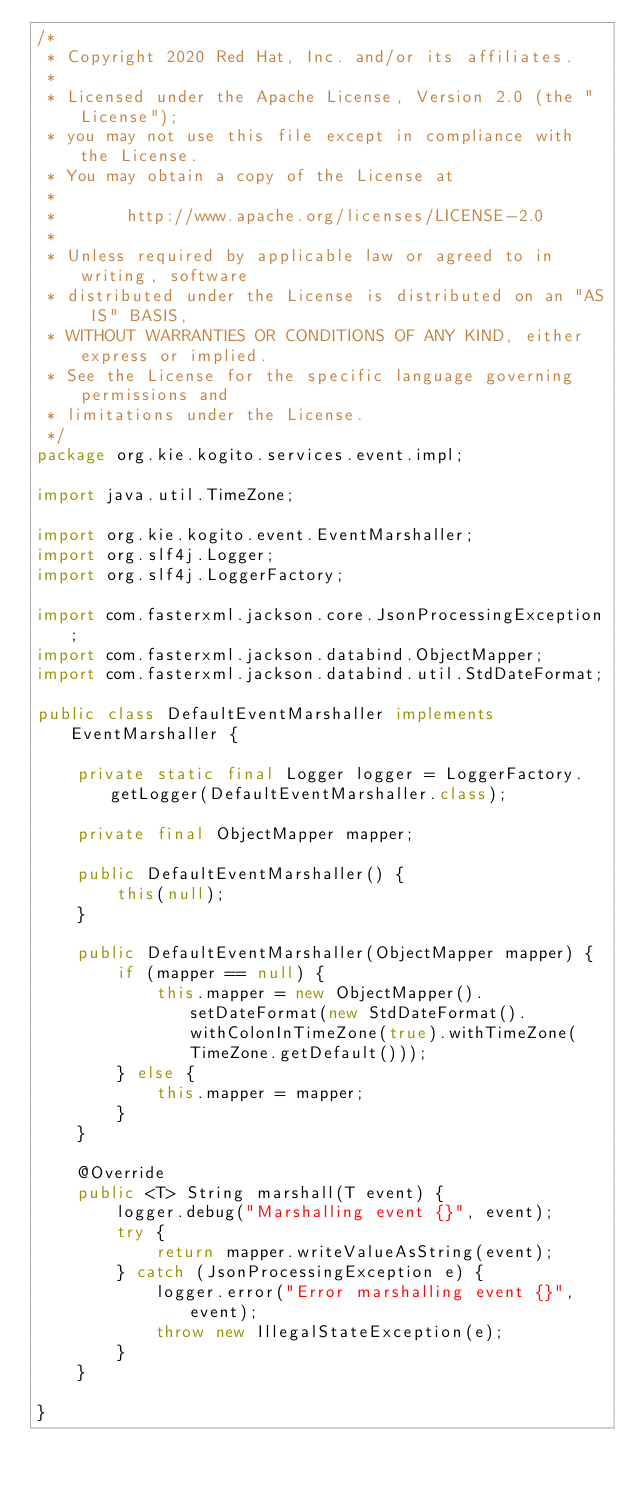<code> <loc_0><loc_0><loc_500><loc_500><_Java_>/*
 * Copyright 2020 Red Hat, Inc. and/or its affiliates.
 *
 * Licensed under the Apache License, Version 2.0 (the "License");
 * you may not use this file except in compliance with the License.
 * You may obtain a copy of the License at
 *
 *       http://www.apache.org/licenses/LICENSE-2.0
 *
 * Unless required by applicable law or agreed to in writing, software
 * distributed under the License is distributed on an "AS IS" BASIS,
 * WITHOUT WARRANTIES OR CONDITIONS OF ANY KIND, either express or implied.
 * See the License for the specific language governing permissions and
 * limitations under the License.
 */
package org.kie.kogito.services.event.impl;

import java.util.TimeZone;

import org.kie.kogito.event.EventMarshaller;
import org.slf4j.Logger;
import org.slf4j.LoggerFactory;

import com.fasterxml.jackson.core.JsonProcessingException;
import com.fasterxml.jackson.databind.ObjectMapper;
import com.fasterxml.jackson.databind.util.StdDateFormat;

public class DefaultEventMarshaller implements EventMarshaller {

    private static final Logger logger = LoggerFactory.getLogger(DefaultEventMarshaller.class);

    private final ObjectMapper mapper;

    public DefaultEventMarshaller() {
        this(null);
    }

    public DefaultEventMarshaller(ObjectMapper mapper) {
        if (mapper == null) {
            this.mapper = new ObjectMapper().setDateFormat(new StdDateFormat().withColonInTimeZone(true).withTimeZone(TimeZone.getDefault()));
        } else {
            this.mapper = mapper;
        }
    }

    @Override
    public <T> String marshall(T event) {
        logger.debug("Marshalling event {}", event);
        try {
            return mapper.writeValueAsString(event);
        } catch (JsonProcessingException e) {
            logger.error("Error marshalling event {}", event);
            throw new IllegalStateException(e);
        }
    }

}
</code> 